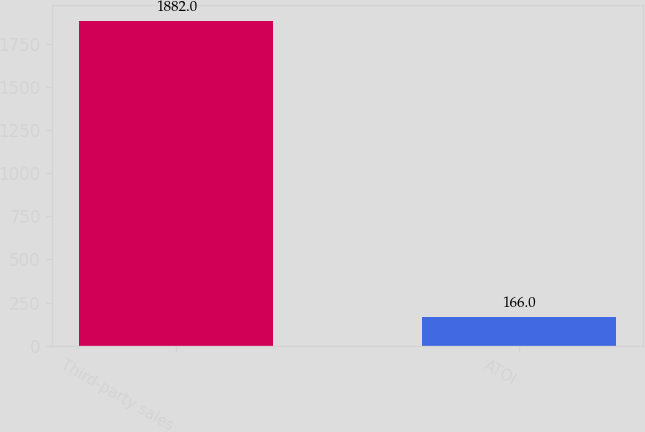Convert chart to OTSL. <chart><loc_0><loc_0><loc_500><loc_500><bar_chart><fcel>Third-party sales<fcel>ATOI<nl><fcel>1882<fcel>166<nl></chart> 